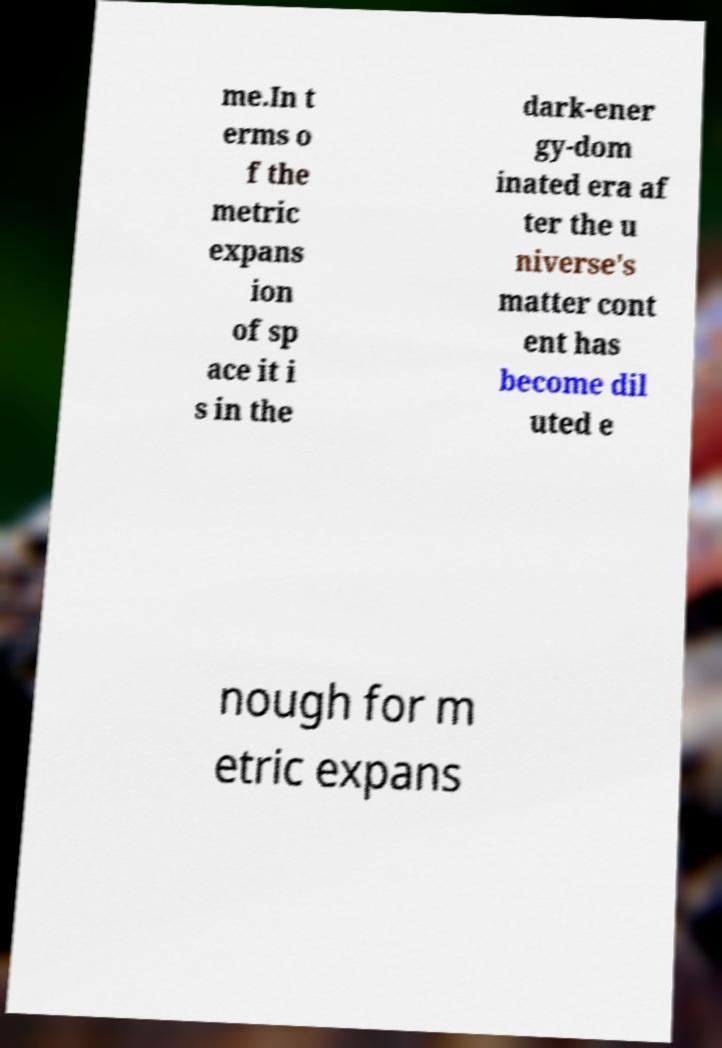Please identify and transcribe the text found in this image. me.In t erms o f the metric expans ion of sp ace it i s in the dark-ener gy-dom inated era af ter the u niverse's matter cont ent has become dil uted e nough for m etric expans 